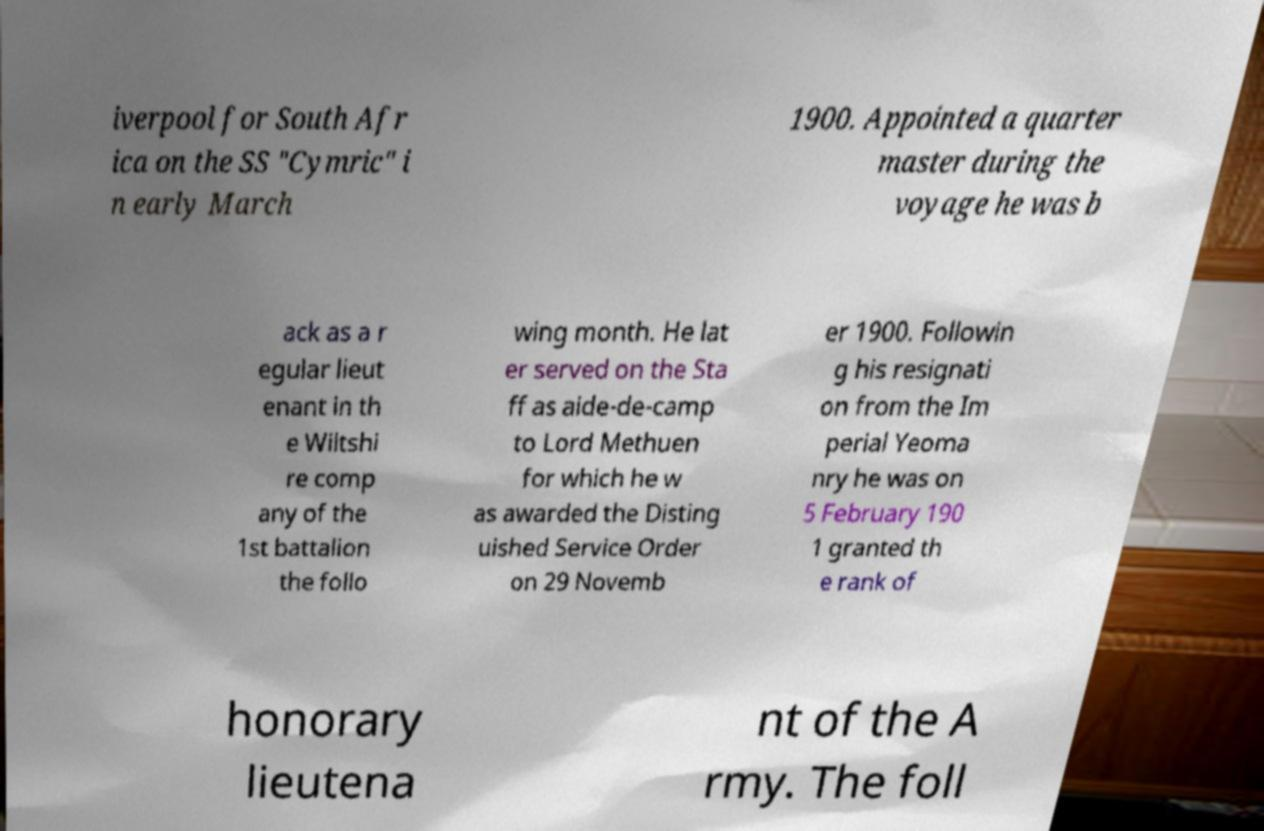Can you read and provide the text displayed in the image?This photo seems to have some interesting text. Can you extract and type it out for me? iverpool for South Afr ica on the SS "Cymric" i n early March 1900. Appointed a quarter master during the voyage he was b ack as a r egular lieut enant in th e Wiltshi re comp any of the 1st battalion the follo wing month. He lat er served on the Sta ff as aide-de-camp to Lord Methuen for which he w as awarded the Disting uished Service Order on 29 Novemb er 1900. Followin g his resignati on from the Im perial Yeoma nry he was on 5 February 190 1 granted th e rank of honorary lieutena nt of the A rmy. The foll 